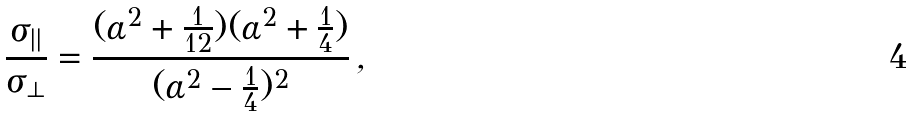Convert formula to latex. <formula><loc_0><loc_0><loc_500><loc_500>\frac { \sigma _ { | | } } { \sigma _ { \perp } } = \frac { ( \alpha ^ { 2 } + \frac { 1 } { 1 2 } ) ( \alpha ^ { 2 } + \frac { 1 } { 4 } ) } { ( \alpha ^ { 2 } - \frac { 1 } { 4 } ) ^ { 2 } } \, ,</formula> 